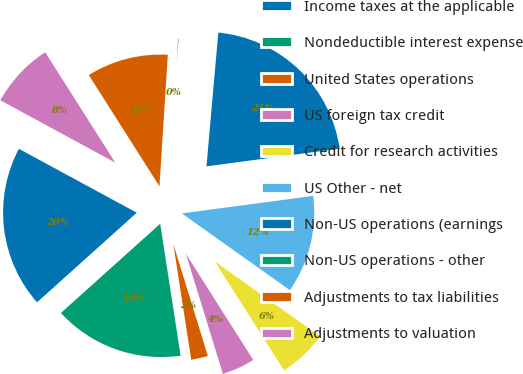<chart> <loc_0><loc_0><loc_500><loc_500><pie_chart><fcel>Income taxes at the applicable<fcel>Nondeductible interest expense<fcel>United States operations<fcel>US foreign tax credit<fcel>Credit for research activities<fcel>US Other - net<fcel>Non-US operations (earnings<fcel>Non-US operations - other<fcel>Adjustments to tax liabilities<fcel>Adjustments to valuation<nl><fcel>19.56%<fcel>15.79%<fcel>2.32%<fcel>4.24%<fcel>6.17%<fcel>11.94%<fcel>21.49%<fcel>0.39%<fcel>10.02%<fcel>8.09%<nl></chart> 